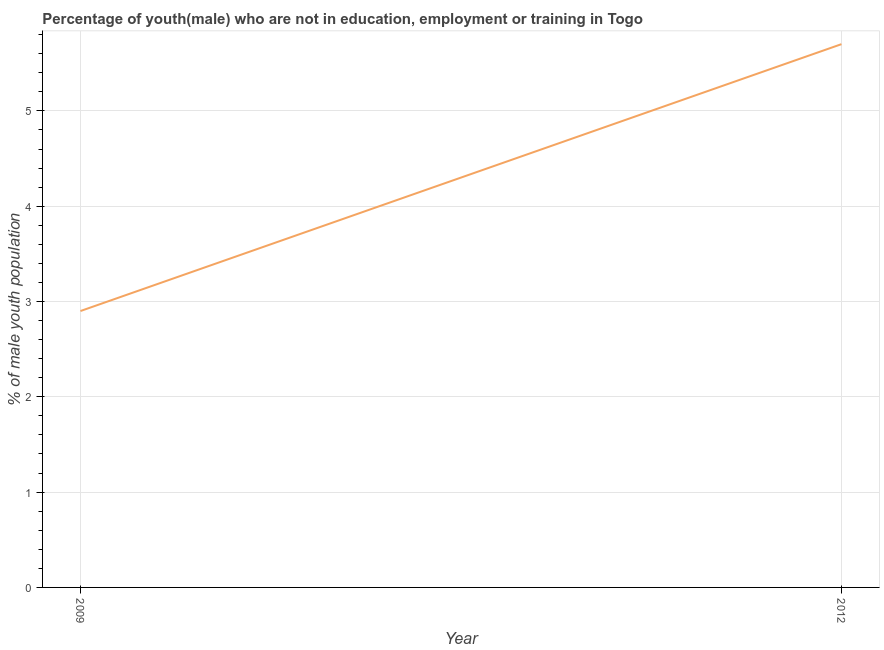What is the unemployed male youth population in 2012?
Make the answer very short. 5.7. Across all years, what is the maximum unemployed male youth population?
Ensure brevity in your answer.  5.7. Across all years, what is the minimum unemployed male youth population?
Offer a terse response. 2.9. In which year was the unemployed male youth population minimum?
Offer a terse response. 2009. What is the sum of the unemployed male youth population?
Your response must be concise. 8.6. What is the difference between the unemployed male youth population in 2009 and 2012?
Provide a succinct answer. -2.8. What is the average unemployed male youth population per year?
Keep it short and to the point. 4.3. What is the median unemployed male youth population?
Give a very brief answer. 4.3. In how many years, is the unemployed male youth population greater than 1.6 %?
Provide a succinct answer. 2. What is the ratio of the unemployed male youth population in 2009 to that in 2012?
Provide a short and direct response. 0.51. How many years are there in the graph?
Ensure brevity in your answer.  2. What is the difference between two consecutive major ticks on the Y-axis?
Your answer should be very brief. 1. Are the values on the major ticks of Y-axis written in scientific E-notation?
Keep it short and to the point. No. Does the graph contain grids?
Your response must be concise. Yes. What is the title of the graph?
Your response must be concise. Percentage of youth(male) who are not in education, employment or training in Togo. What is the label or title of the X-axis?
Your answer should be compact. Year. What is the label or title of the Y-axis?
Provide a short and direct response. % of male youth population. What is the % of male youth population of 2009?
Ensure brevity in your answer.  2.9. What is the % of male youth population in 2012?
Keep it short and to the point. 5.7. What is the difference between the % of male youth population in 2009 and 2012?
Ensure brevity in your answer.  -2.8. What is the ratio of the % of male youth population in 2009 to that in 2012?
Give a very brief answer. 0.51. 